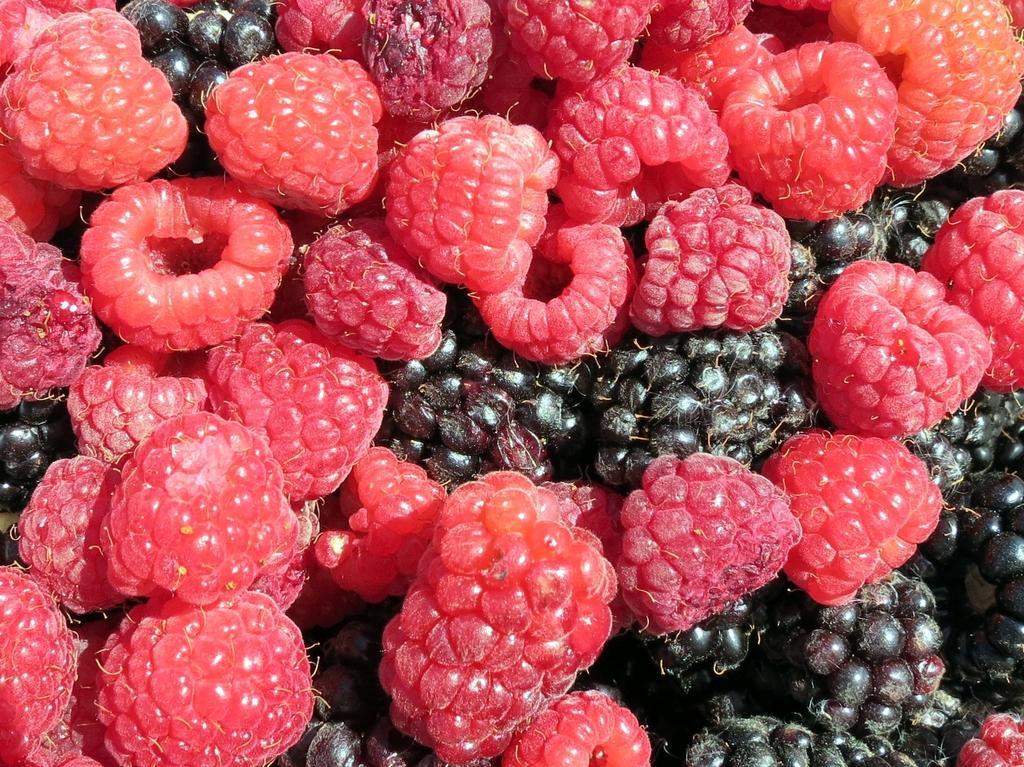In one or two sentences, can you explain what this image depicts? In this picture we can see boysenberries are there. 